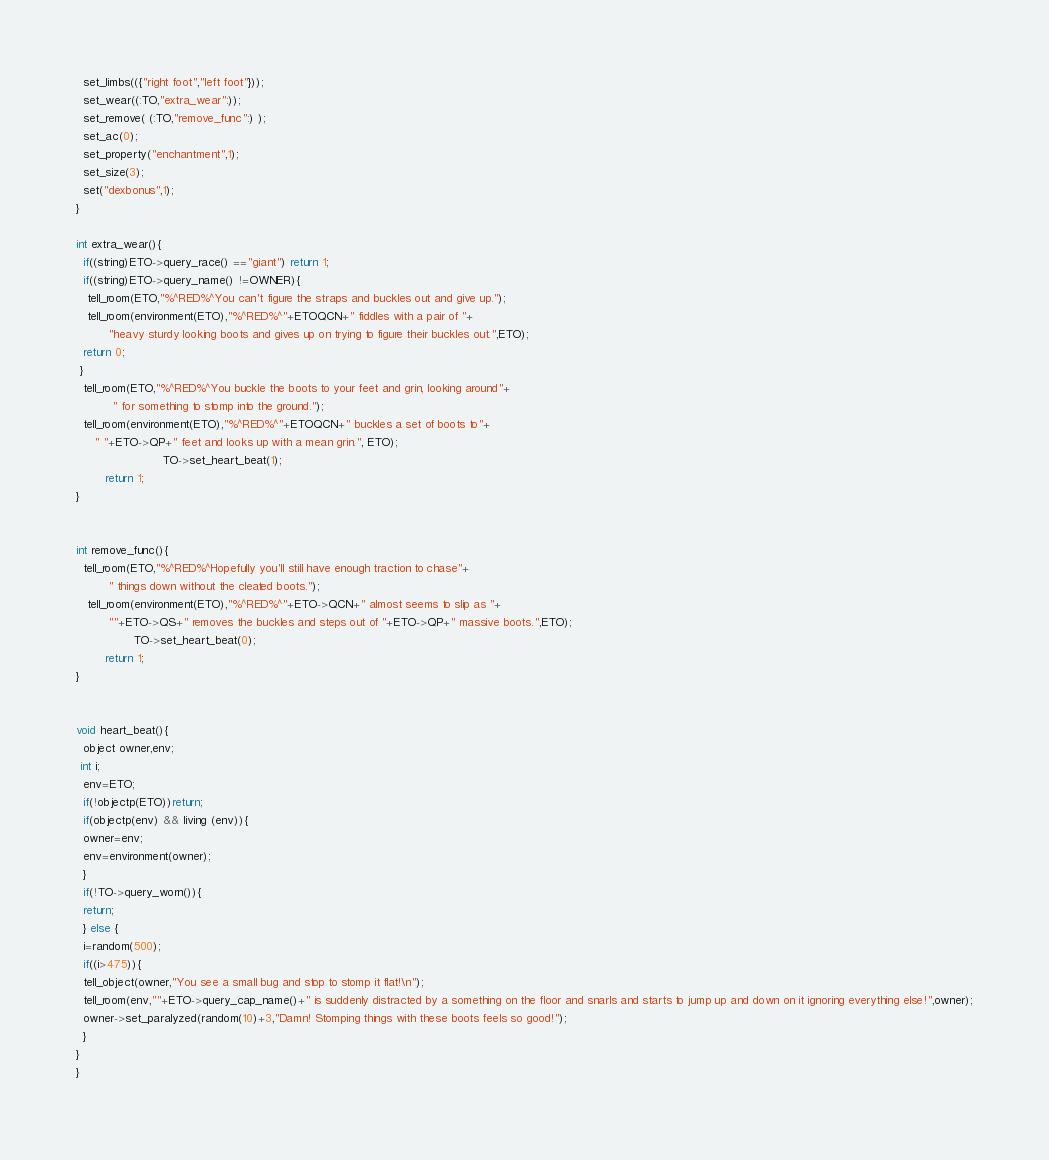Convert code to text. <code><loc_0><loc_0><loc_500><loc_500><_C_>  set_limbs(({"right foot","left foot"}));
  set_wear((:TO,"extra_wear":));
  set_remove( (:TO,"remove_func":) );
  set_ac(0);
  set_property("enchantment",1);
  set_size(3);
  set("dexbonus",1);
}

int extra_wear(){
  if((string)ETO->query_race() =="giant") return 1;
  if((string)ETO->query_name() !=OWNER){
   tell_room(ETO,"%^RED%^You can't figure the straps and buckles out and give up.");
   tell_room(environment(ETO),"%^RED%^"+ETOQCN+" fiddles with a pair of "+
         "heavy sturdy looking boots and gives up on trying to figure their buckles out.",ETO);
  return 0;
 }
  tell_room(ETO,"%^RED%^You buckle the boots to your feet and grin, looking around"+
          " for something to stomp into the ground.");
  tell_room(environment(ETO),"%^RED%^"+ETOQCN+" buckles a set of boots to"+
     " "+ETO->QP+" feet and looks up with a mean grin.", ETO);
                        TO->set_heart_beat(1);
        return 1;
}


int remove_func(){
  tell_room(ETO,"%^RED%^Hopefully you'll still have enough traction to chase"+
         " things down without the cleated boots.");
   tell_room(environment(ETO),"%^RED%^"+ETO->QCN+" almost seems to slip as "+
         ""+ETO->QS+" removes the buckles and steps out of "+ETO->QP+" massive boots.",ETO);
                TO->set_heart_beat(0);
        return 1;
}


void heart_beat(){
  object owner,env;
 int i;
  env=ETO;
  if(!objectp(ETO))return;
  if(objectp(env) && living (env)){
  owner=env;
  env=environment(owner);
  }
  if(!TO->query_worn()){
  return;  
  } else {
  i=random(500);
  if((i>475)){
  tell_object(owner,"You see a small bug and stop to stomp it flat!\n");
  tell_room(env,""+ETO->query_cap_name()+" is suddenly distracted by a something on the floor and snarls and starts to jump up and down on it ignoring everything else!",owner);
  owner->set_paralyzed(random(10)+3,"Damn! Stomping things with these boots feels so good!");
  }
}
}
</code> 